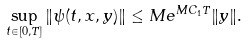<formula> <loc_0><loc_0><loc_500><loc_500>\sup _ { t \in [ 0 , T ] } \| \psi ( t , x , y ) \| \leq M e ^ { M C _ { 1 } T } \| y \| .</formula> 